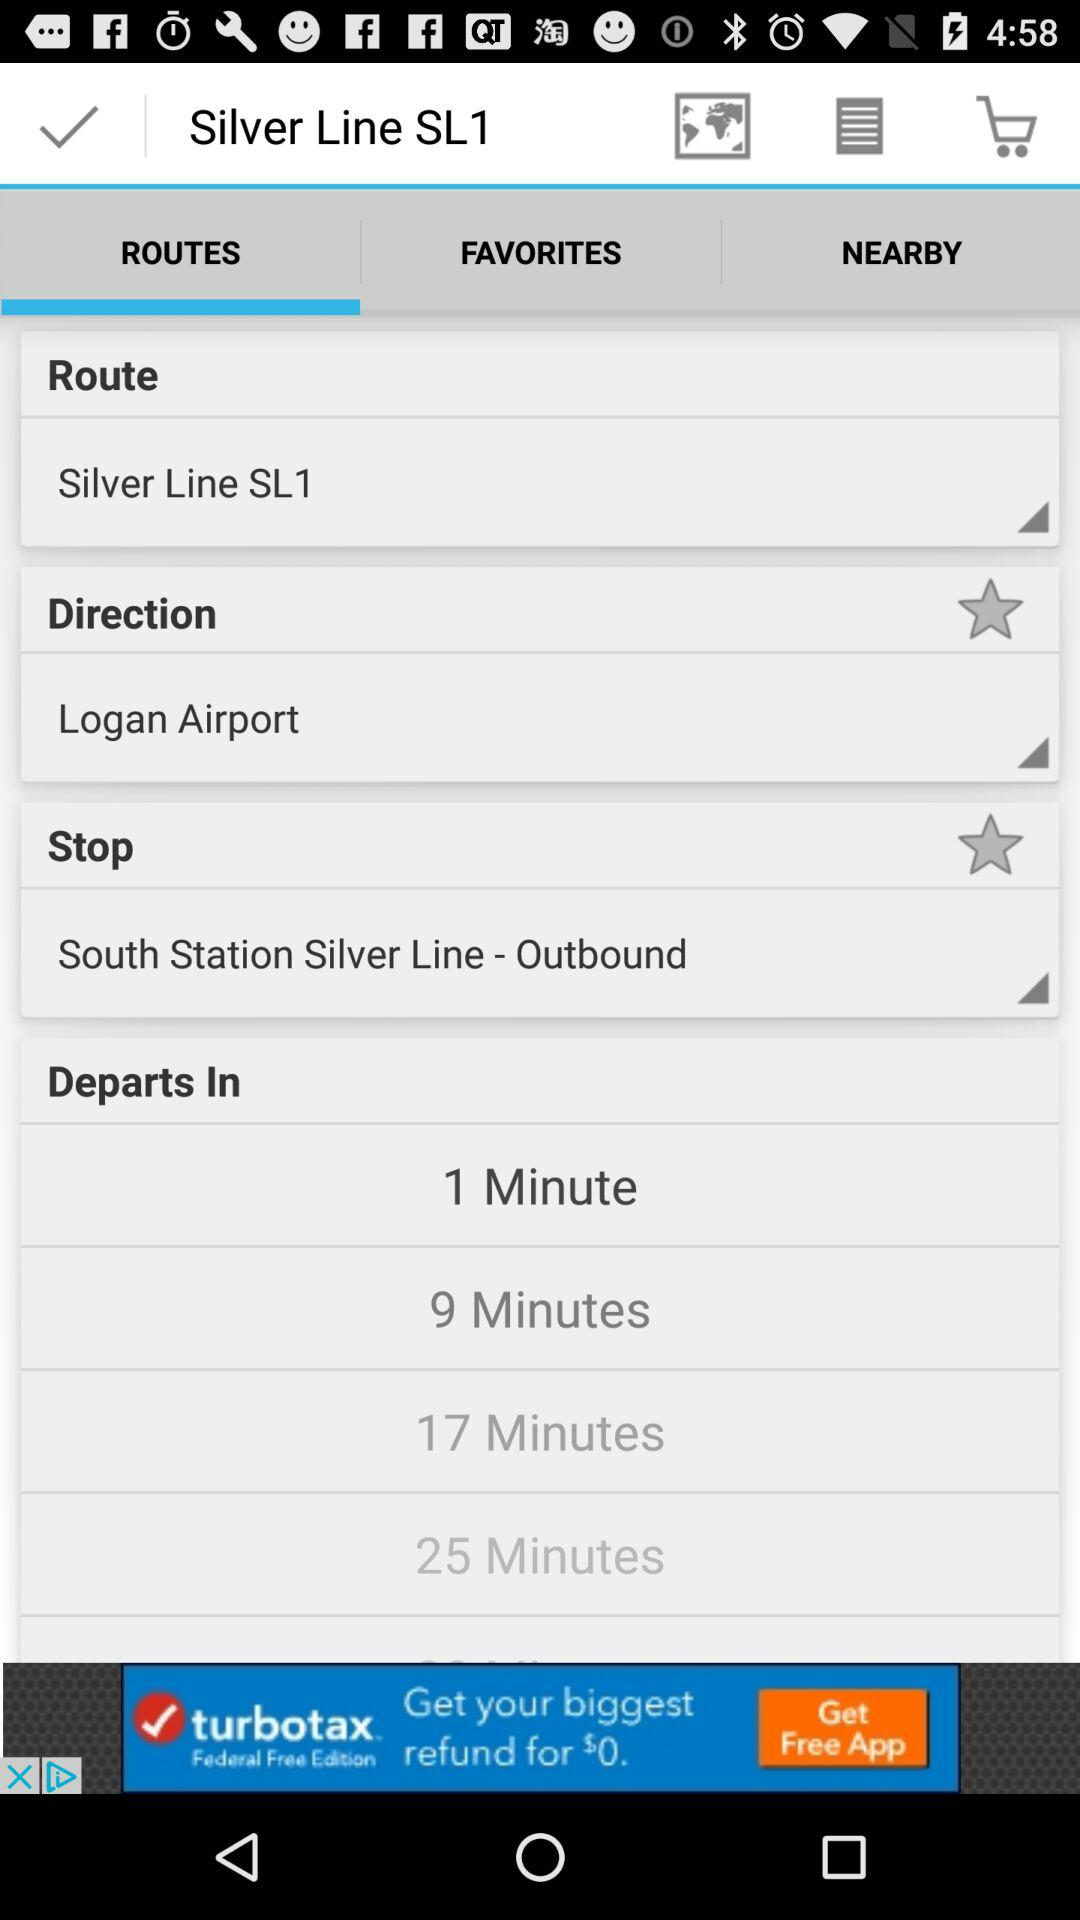How many minutes are there between the 1 minute and 9 minute departures?
Answer the question using a single word or phrase. 8 